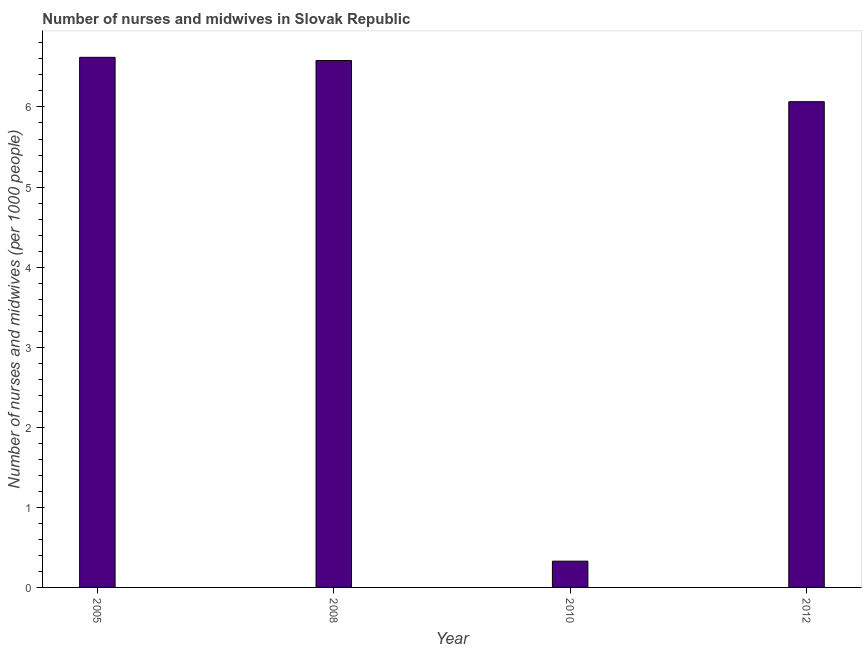Does the graph contain any zero values?
Your response must be concise. No. Does the graph contain grids?
Make the answer very short. No. What is the title of the graph?
Offer a terse response. Number of nurses and midwives in Slovak Republic. What is the label or title of the Y-axis?
Keep it short and to the point. Number of nurses and midwives (per 1000 people). What is the number of nurses and midwives in 2008?
Your response must be concise. 6.58. Across all years, what is the maximum number of nurses and midwives?
Make the answer very short. 6.62. Across all years, what is the minimum number of nurses and midwives?
Provide a succinct answer. 0.33. In which year was the number of nurses and midwives minimum?
Provide a short and direct response. 2010. What is the sum of the number of nurses and midwives?
Give a very brief answer. 19.59. What is the difference between the number of nurses and midwives in 2005 and 2012?
Your answer should be very brief. 0.55. What is the average number of nurses and midwives per year?
Keep it short and to the point. 4.9. What is the median number of nurses and midwives?
Your answer should be compact. 6.32. Do a majority of the years between 2010 and 2012 (inclusive) have number of nurses and midwives greater than 0.8 ?
Keep it short and to the point. No. What is the ratio of the number of nurses and midwives in 2008 to that in 2010?
Give a very brief answer. 20.06. What is the difference between the highest and the second highest number of nurses and midwives?
Provide a succinct answer. 0.04. What is the difference between the highest and the lowest number of nurses and midwives?
Offer a very short reply. 6.29. In how many years, is the number of nurses and midwives greater than the average number of nurses and midwives taken over all years?
Your response must be concise. 3. How many bars are there?
Your answer should be very brief. 4. How many years are there in the graph?
Give a very brief answer. 4. What is the difference between two consecutive major ticks on the Y-axis?
Offer a very short reply. 1. What is the Number of nurses and midwives (per 1000 people) of 2005?
Ensure brevity in your answer.  6.62. What is the Number of nurses and midwives (per 1000 people) of 2008?
Offer a terse response. 6.58. What is the Number of nurses and midwives (per 1000 people) in 2010?
Give a very brief answer. 0.33. What is the Number of nurses and midwives (per 1000 people) of 2012?
Offer a very short reply. 6.07. What is the difference between the Number of nurses and midwives (per 1000 people) in 2005 and 2010?
Offer a very short reply. 6.29. What is the difference between the Number of nurses and midwives (per 1000 people) in 2005 and 2012?
Your response must be concise. 0.55. What is the difference between the Number of nurses and midwives (per 1000 people) in 2008 and 2010?
Offer a terse response. 6.25. What is the difference between the Number of nurses and midwives (per 1000 people) in 2008 and 2012?
Your answer should be very brief. 0.51. What is the difference between the Number of nurses and midwives (per 1000 people) in 2010 and 2012?
Make the answer very short. -5.74. What is the ratio of the Number of nurses and midwives (per 1000 people) in 2005 to that in 2008?
Make the answer very short. 1.01. What is the ratio of the Number of nurses and midwives (per 1000 people) in 2005 to that in 2010?
Provide a short and direct response. 20.18. What is the ratio of the Number of nurses and midwives (per 1000 people) in 2005 to that in 2012?
Offer a very short reply. 1.09. What is the ratio of the Number of nurses and midwives (per 1000 people) in 2008 to that in 2010?
Offer a terse response. 20.06. What is the ratio of the Number of nurses and midwives (per 1000 people) in 2008 to that in 2012?
Provide a succinct answer. 1.08. What is the ratio of the Number of nurses and midwives (per 1000 people) in 2010 to that in 2012?
Offer a very short reply. 0.05. 